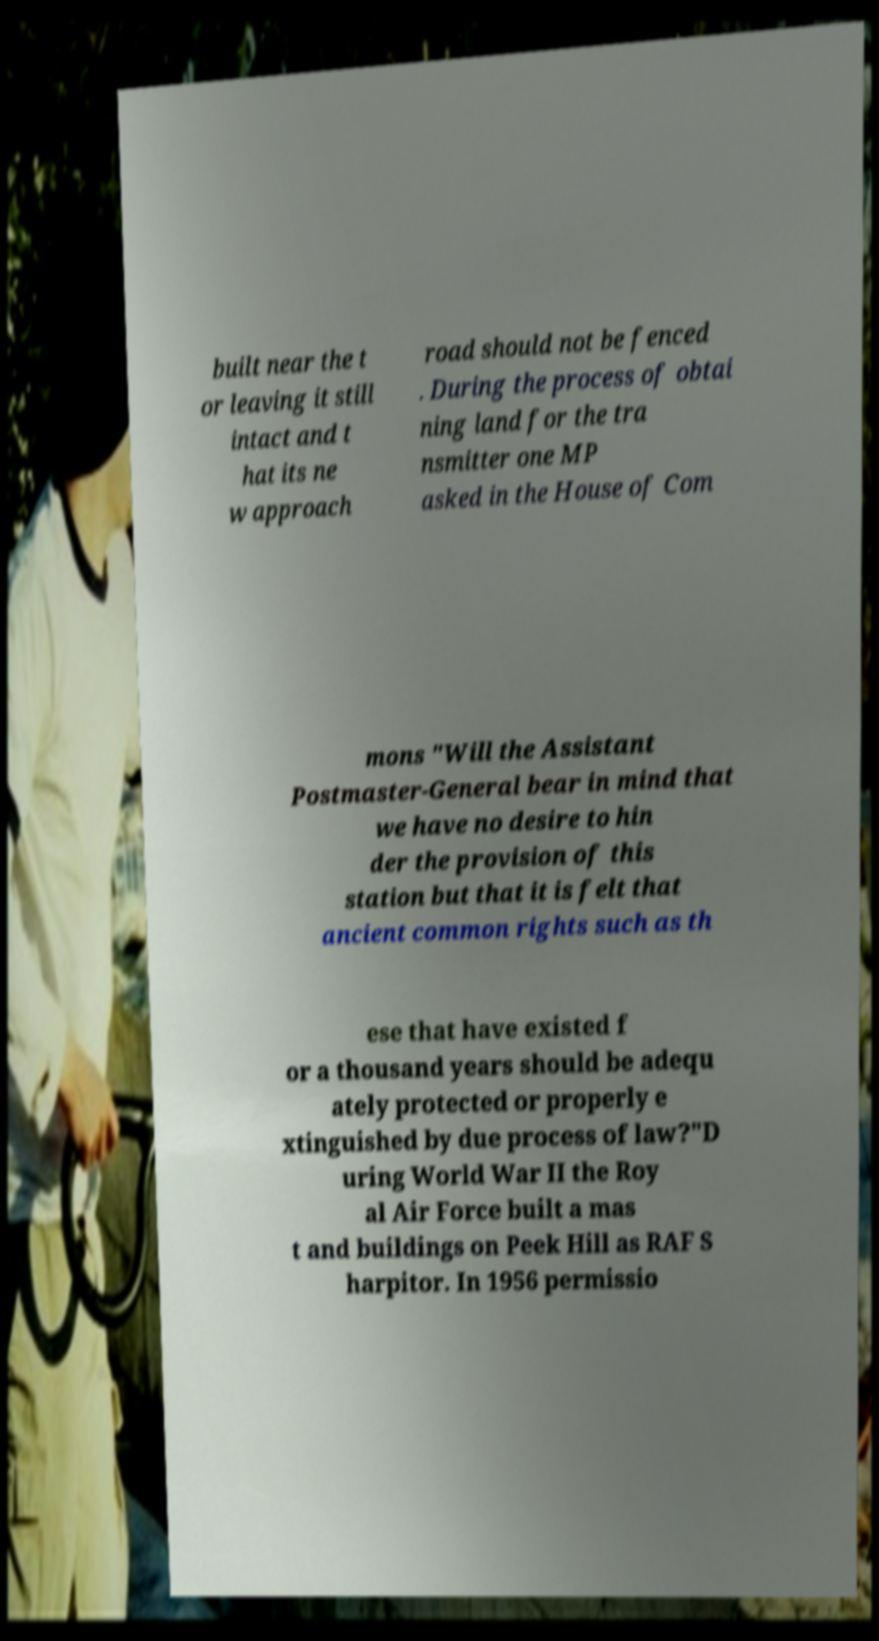Can you read and provide the text displayed in the image?This photo seems to have some interesting text. Can you extract and type it out for me? built near the t or leaving it still intact and t hat its ne w approach road should not be fenced . During the process of obtai ning land for the tra nsmitter one MP asked in the House of Com mons "Will the Assistant Postmaster-General bear in mind that we have no desire to hin der the provision of this station but that it is felt that ancient common rights such as th ese that have existed f or a thousand years should be adequ ately protected or properly e xtinguished by due process of law?"D uring World War II the Roy al Air Force built a mas t and buildings on Peek Hill as RAF S harpitor. In 1956 permissio 